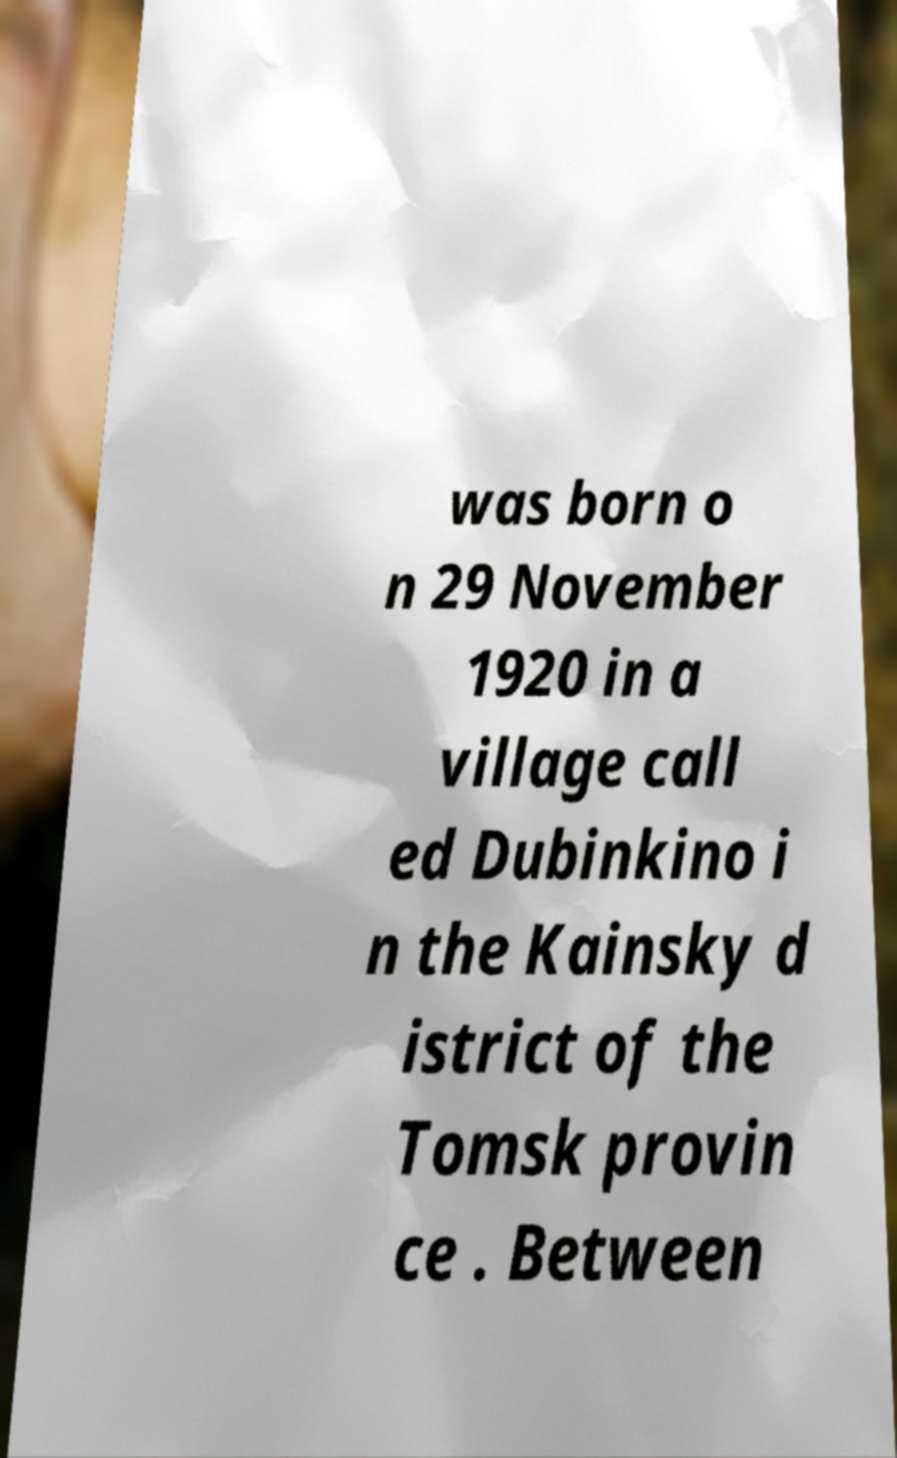What messages or text are displayed in this image? I need them in a readable, typed format. was born o n 29 November 1920 in a village call ed Dubinkino i n the Kainsky d istrict of the Tomsk provin ce . Between 